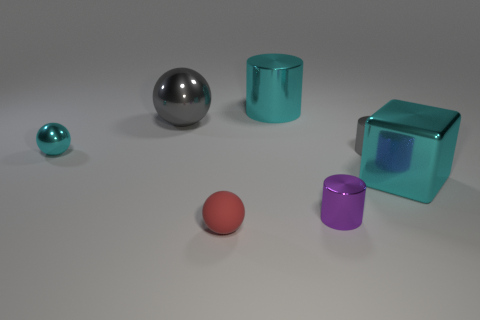Subtract all large metal cylinders. How many cylinders are left? 2 Add 3 large gray balls. How many objects exist? 10 Subtract all gray cylinders. How many cylinders are left? 2 Subtract all balls. How many objects are left? 4 Subtract 1 cyan cylinders. How many objects are left? 6 Subtract 2 balls. How many balls are left? 1 Subtract all brown blocks. Subtract all cyan balls. How many blocks are left? 1 Subtract all yellow balls. How many purple cylinders are left? 1 Subtract all cyan objects. Subtract all gray cylinders. How many objects are left? 3 Add 3 small gray things. How many small gray things are left? 4 